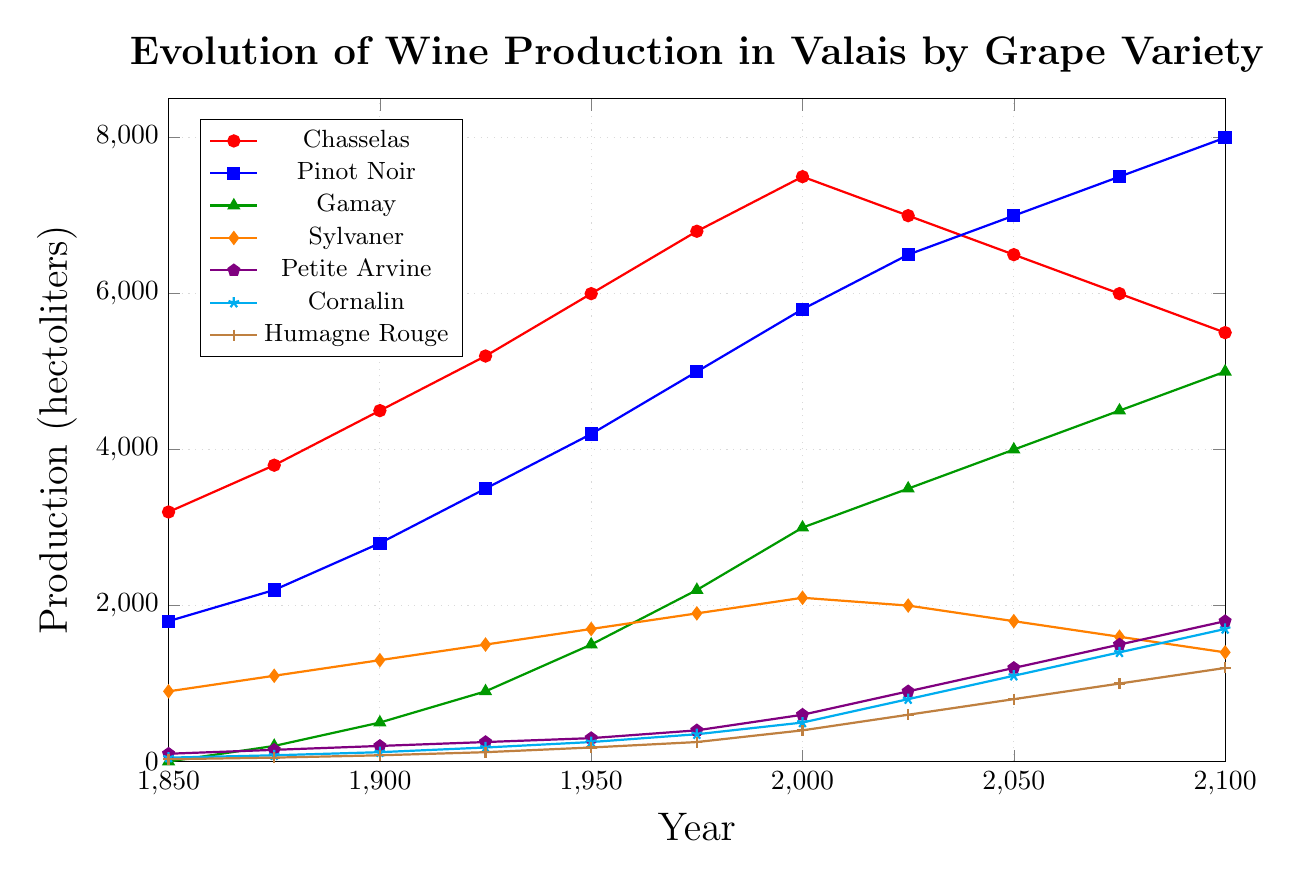Which grape variety had the highest production in the year 1900? In the year 1900, the production values for each grape variety are: Chasselas (4500), Pinot Noir (2800), Gamay (500), Sylvaner (1300), Petite Arvine (200), Cornalin (120), Humagne Rouge (80). The highest value among these is for Chasselas.
Answer: Chasselas How has the production of Pinot Noir changed from 1850 to 2100? The production values of Pinot Noir from 1850 to 2100 are: 1800, 2200, 2800, 3500, 4200, 5000, 5800, 6500, 7000, 7500, 8000. Starting from 1800 in 1850 and ending at 8000 in 2100, there has been a steady increase in production with a significant rise from 1950 onwards.
Answer: Increased By how much did production of Gamay increase between 1900 and 1950? In 1900, Gamay production was 500 hectoliters and in 1950 it was 1500 hectoliters. The increase in production is 1500 - 500 = 1000 hectoliters.
Answer: 1000 hectoliters Which grape variety had the lowest production in 1850 and what was its value? In 1850, the production values for the grape varieties are: Chasselas (3200), Pinot Noir (1800), Gamay (0), Sylvaner (900), Petite Arvine (100), Cornalin (50), Humagne Rouge (30). The lowest production value is for Gamay with 0 hectoliters.
Answer: Gamay, 0 hectoliters What is the trend in production for Petite Arvine from 1850 to 2100? The production values for Petite Arvine from 1850 to 2100 are: 100, 150, 200, 250, 300, 400, 600, 900, 1200, 1500, 1800. The trend shows a steady increase in production over time, with notable jumps especially after 1950.
Answer: Increasing By how much did the production of Cornalin increase from 1850 to 2100? In 1850, Cornalin production was 50 hectoliters and in 2100 it is 1700 hectoliters. The increase is calculated as 1700 - 50 = 1650 hectoliters.
Answer: 1650 hectoliters What is the average production of Humagne Rouge from 1850 to 2100? The production values for Humagne Rouge from 1850 to 2100 are: 30, 50, 80, 120, 180, 250, 400, 600, 800, 1000, 1200. Sum these values: 30+50+80+120+180+250+400+600+800+1000+1200 = 4710. The average production is 4710 / 11 ≈ 428 hectoliters.
Answer: 428 hectoliters Which grape variety saw the largest increase in production from 1975 to 2000? From 1975 to 2000, the production changes are: Chasselas (7500 - 6800 = 700), Pinot Noir (5800 - 5000 = 800), Gamay (3000 - 2200 = 800), Sylvaner (2100 - 1900 = 200), Petite Arvine (600 - 400 = 200), Cornalin (500 - 350 = 150), Humagne Rouge (400 - 250 = 150). Gamay and Pinot Noir saw the largest increase with 800 hectoliters each.
Answer: Gamay and Pinot Noir How did the production of Sylvaner change between 2025 and 2100? The production values of Sylvaner are 2025 (2000 hectoliters) and 2100 (1400 hectoliters). The change is calculated as 1400 - 2000 = -600 hectoliters. Therefore, there was a decrease of 600 hectoliters.
Answer: Decreased by 600 hectoliters Which grape varieties have a production greater than 1000 hectoliters in 2100? In 2100, the production values are: Chasselas (5500), Pinot Noir (8000), Gamay (5000), Sylvaner (1400), Petite Arvine (1800), Cornalin (1700), Humagne Rouge (1200). All varieties except Humagne Rouge are greater than 1000 hectoliters.
Answer: Chasselas, Pinot Noir, Gamay, Sylvaner, Petite Arvine, Cornalin 